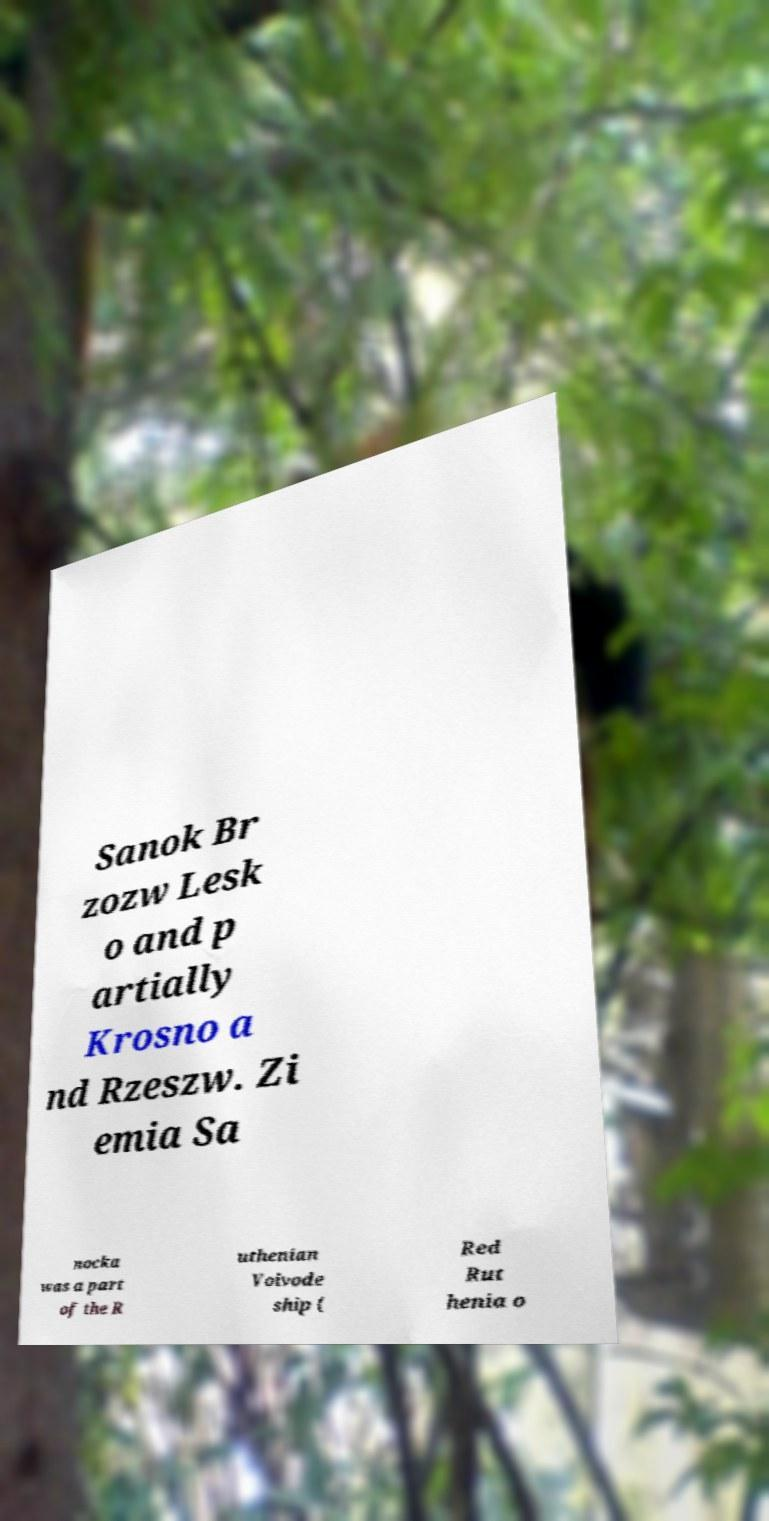Can you accurately transcribe the text from the provided image for me? Sanok Br zozw Lesk o and p artially Krosno a nd Rzeszw. Zi emia Sa nocka was a part of the R uthenian Voivode ship ( Red Rut henia o 